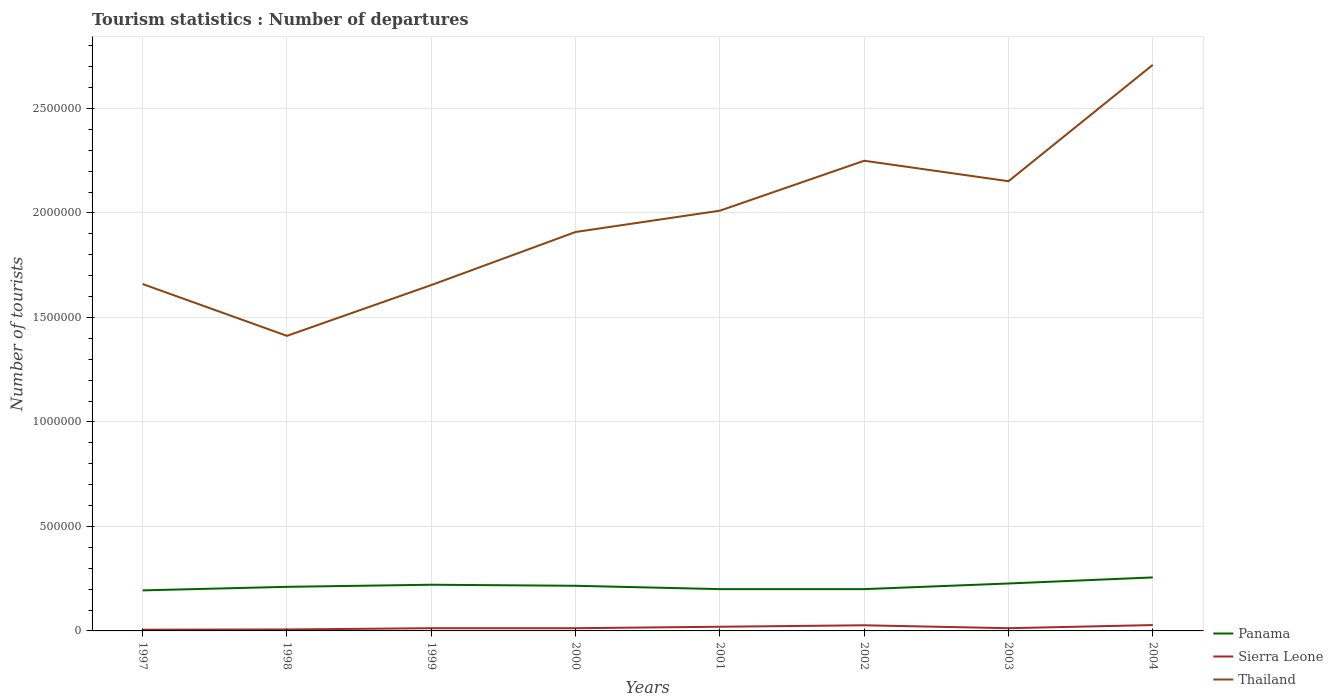How many different coloured lines are there?
Give a very brief answer. 3. Does the line corresponding to Sierra Leone intersect with the line corresponding to Thailand?
Keep it short and to the point. No. Across all years, what is the maximum number of tourist departures in Thailand?
Provide a succinct answer. 1.41e+06. What is the total number of tourist departures in Thailand in the graph?
Provide a short and direct response. -5.90e+05. What is the difference between the highest and the second highest number of tourist departures in Thailand?
Your answer should be compact. 1.30e+06. What is the difference between the highest and the lowest number of tourist departures in Thailand?
Provide a succinct answer. 4. Is the number of tourist departures in Thailand strictly greater than the number of tourist departures in Panama over the years?
Make the answer very short. No. How many years are there in the graph?
Provide a short and direct response. 8. Are the values on the major ticks of Y-axis written in scientific E-notation?
Offer a terse response. No. Does the graph contain any zero values?
Provide a short and direct response. No. Where does the legend appear in the graph?
Keep it short and to the point. Bottom right. How many legend labels are there?
Give a very brief answer. 3. How are the legend labels stacked?
Give a very brief answer. Vertical. What is the title of the graph?
Offer a very short reply. Tourism statistics : Number of departures. Does "Canada" appear as one of the legend labels in the graph?
Your response must be concise. No. What is the label or title of the X-axis?
Your response must be concise. Years. What is the label or title of the Y-axis?
Offer a terse response. Number of tourists. What is the Number of tourists of Panama in 1997?
Offer a terse response. 1.94e+05. What is the Number of tourists in Sierra Leone in 1997?
Offer a very short reply. 6000. What is the Number of tourists of Thailand in 1997?
Your answer should be compact. 1.66e+06. What is the Number of tourists of Panama in 1998?
Provide a short and direct response. 2.11e+05. What is the Number of tourists in Sierra Leone in 1998?
Your response must be concise. 7000. What is the Number of tourists of Thailand in 1998?
Provide a succinct answer. 1.41e+06. What is the Number of tourists in Panama in 1999?
Make the answer very short. 2.21e+05. What is the Number of tourists of Sierra Leone in 1999?
Offer a terse response. 1.30e+04. What is the Number of tourists in Thailand in 1999?
Ensure brevity in your answer.  1.66e+06. What is the Number of tourists of Panama in 2000?
Keep it short and to the point. 2.16e+05. What is the Number of tourists in Sierra Leone in 2000?
Ensure brevity in your answer.  1.30e+04. What is the Number of tourists of Thailand in 2000?
Make the answer very short. 1.91e+06. What is the Number of tourists in Panama in 2001?
Give a very brief answer. 2.00e+05. What is the Number of tourists of Sierra Leone in 2001?
Offer a very short reply. 2.00e+04. What is the Number of tourists of Thailand in 2001?
Ensure brevity in your answer.  2.01e+06. What is the Number of tourists of Sierra Leone in 2002?
Make the answer very short. 2.70e+04. What is the Number of tourists of Thailand in 2002?
Offer a terse response. 2.25e+06. What is the Number of tourists in Panama in 2003?
Your answer should be compact. 2.27e+05. What is the Number of tourists in Sierra Leone in 2003?
Provide a succinct answer. 1.30e+04. What is the Number of tourists of Thailand in 2003?
Offer a very short reply. 2.15e+06. What is the Number of tourists of Panama in 2004?
Offer a terse response. 2.56e+05. What is the Number of tourists of Sierra Leone in 2004?
Offer a terse response. 2.80e+04. What is the Number of tourists in Thailand in 2004?
Provide a short and direct response. 2.71e+06. Across all years, what is the maximum Number of tourists of Panama?
Offer a very short reply. 2.56e+05. Across all years, what is the maximum Number of tourists of Sierra Leone?
Provide a succinct answer. 2.80e+04. Across all years, what is the maximum Number of tourists of Thailand?
Ensure brevity in your answer.  2.71e+06. Across all years, what is the minimum Number of tourists of Panama?
Give a very brief answer. 1.94e+05. Across all years, what is the minimum Number of tourists of Sierra Leone?
Provide a short and direct response. 6000. Across all years, what is the minimum Number of tourists of Thailand?
Your response must be concise. 1.41e+06. What is the total Number of tourists in Panama in the graph?
Your response must be concise. 1.72e+06. What is the total Number of tourists of Sierra Leone in the graph?
Give a very brief answer. 1.27e+05. What is the total Number of tourists in Thailand in the graph?
Give a very brief answer. 1.58e+07. What is the difference between the Number of tourists in Panama in 1997 and that in 1998?
Your response must be concise. -1.70e+04. What is the difference between the Number of tourists of Sierra Leone in 1997 and that in 1998?
Provide a short and direct response. -1000. What is the difference between the Number of tourists of Thailand in 1997 and that in 1998?
Ensure brevity in your answer.  2.48e+05. What is the difference between the Number of tourists in Panama in 1997 and that in 1999?
Keep it short and to the point. -2.70e+04. What is the difference between the Number of tourists in Sierra Leone in 1997 and that in 1999?
Your answer should be very brief. -7000. What is the difference between the Number of tourists in Panama in 1997 and that in 2000?
Provide a succinct answer. -2.20e+04. What is the difference between the Number of tourists in Sierra Leone in 1997 and that in 2000?
Your answer should be compact. -7000. What is the difference between the Number of tourists in Thailand in 1997 and that in 2000?
Give a very brief answer. -2.49e+05. What is the difference between the Number of tourists in Panama in 1997 and that in 2001?
Provide a short and direct response. -6000. What is the difference between the Number of tourists of Sierra Leone in 1997 and that in 2001?
Provide a succinct answer. -1.40e+04. What is the difference between the Number of tourists of Thailand in 1997 and that in 2001?
Keep it short and to the point. -3.51e+05. What is the difference between the Number of tourists of Panama in 1997 and that in 2002?
Your answer should be very brief. -6000. What is the difference between the Number of tourists in Sierra Leone in 1997 and that in 2002?
Offer a very short reply. -2.10e+04. What is the difference between the Number of tourists in Thailand in 1997 and that in 2002?
Offer a terse response. -5.90e+05. What is the difference between the Number of tourists in Panama in 1997 and that in 2003?
Offer a very short reply. -3.30e+04. What is the difference between the Number of tourists of Sierra Leone in 1997 and that in 2003?
Offer a very short reply. -7000. What is the difference between the Number of tourists in Thailand in 1997 and that in 2003?
Make the answer very short. -4.92e+05. What is the difference between the Number of tourists in Panama in 1997 and that in 2004?
Provide a short and direct response. -6.20e+04. What is the difference between the Number of tourists in Sierra Leone in 1997 and that in 2004?
Offer a terse response. -2.20e+04. What is the difference between the Number of tourists in Thailand in 1997 and that in 2004?
Keep it short and to the point. -1.05e+06. What is the difference between the Number of tourists of Panama in 1998 and that in 1999?
Make the answer very short. -10000. What is the difference between the Number of tourists of Sierra Leone in 1998 and that in 1999?
Offer a terse response. -6000. What is the difference between the Number of tourists in Thailand in 1998 and that in 1999?
Your answer should be compact. -2.43e+05. What is the difference between the Number of tourists of Panama in 1998 and that in 2000?
Your response must be concise. -5000. What is the difference between the Number of tourists in Sierra Leone in 1998 and that in 2000?
Give a very brief answer. -6000. What is the difference between the Number of tourists in Thailand in 1998 and that in 2000?
Make the answer very short. -4.97e+05. What is the difference between the Number of tourists in Panama in 1998 and that in 2001?
Offer a terse response. 1.10e+04. What is the difference between the Number of tourists of Sierra Leone in 1998 and that in 2001?
Make the answer very short. -1.30e+04. What is the difference between the Number of tourists in Thailand in 1998 and that in 2001?
Give a very brief answer. -5.99e+05. What is the difference between the Number of tourists in Panama in 1998 and that in 2002?
Offer a very short reply. 1.10e+04. What is the difference between the Number of tourists in Thailand in 1998 and that in 2002?
Give a very brief answer. -8.38e+05. What is the difference between the Number of tourists of Panama in 1998 and that in 2003?
Keep it short and to the point. -1.60e+04. What is the difference between the Number of tourists of Sierra Leone in 1998 and that in 2003?
Keep it short and to the point. -6000. What is the difference between the Number of tourists in Thailand in 1998 and that in 2003?
Make the answer very short. -7.40e+05. What is the difference between the Number of tourists of Panama in 1998 and that in 2004?
Keep it short and to the point. -4.50e+04. What is the difference between the Number of tourists of Sierra Leone in 1998 and that in 2004?
Offer a terse response. -2.10e+04. What is the difference between the Number of tourists in Thailand in 1998 and that in 2004?
Provide a short and direct response. -1.30e+06. What is the difference between the Number of tourists of Thailand in 1999 and that in 2000?
Make the answer very short. -2.54e+05. What is the difference between the Number of tourists in Panama in 1999 and that in 2001?
Keep it short and to the point. 2.10e+04. What is the difference between the Number of tourists of Sierra Leone in 1999 and that in 2001?
Offer a very short reply. -7000. What is the difference between the Number of tourists in Thailand in 1999 and that in 2001?
Keep it short and to the point. -3.56e+05. What is the difference between the Number of tourists in Panama in 1999 and that in 2002?
Your answer should be very brief. 2.10e+04. What is the difference between the Number of tourists in Sierra Leone in 1999 and that in 2002?
Keep it short and to the point. -1.40e+04. What is the difference between the Number of tourists of Thailand in 1999 and that in 2002?
Make the answer very short. -5.95e+05. What is the difference between the Number of tourists in Panama in 1999 and that in 2003?
Provide a short and direct response. -6000. What is the difference between the Number of tourists of Thailand in 1999 and that in 2003?
Your answer should be very brief. -4.97e+05. What is the difference between the Number of tourists of Panama in 1999 and that in 2004?
Your response must be concise. -3.50e+04. What is the difference between the Number of tourists of Sierra Leone in 1999 and that in 2004?
Ensure brevity in your answer.  -1.50e+04. What is the difference between the Number of tourists in Thailand in 1999 and that in 2004?
Provide a short and direct response. -1.05e+06. What is the difference between the Number of tourists of Panama in 2000 and that in 2001?
Your answer should be compact. 1.60e+04. What is the difference between the Number of tourists of Sierra Leone in 2000 and that in 2001?
Give a very brief answer. -7000. What is the difference between the Number of tourists of Thailand in 2000 and that in 2001?
Make the answer very short. -1.02e+05. What is the difference between the Number of tourists in Panama in 2000 and that in 2002?
Your answer should be very brief. 1.60e+04. What is the difference between the Number of tourists of Sierra Leone in 2000 and that in 2002?
Provide a succinct answer. -1.40e+04. What is the difference between the Number of tourists of Thailand in 2000 and that in 2002?
Your response must be concise. -3.41e+05. What is the difference between the Number of tourists in Panama in 2000 and that in 2003?
Provide a succinct answer. -1.10e+04. What is the difference between the Number of tourists in Sierra Leone in 2000 and that in 2003?
Your answer should be very brief. 0. What is the difference between the Number of tourists of Thailand in 2000 and that in 2003?
Provide a succinct answer. -2.43e+05. What is the difference between the Number of tourists of Sierra Leone in 2000 and that in 2004?
Keep it short and to the point. -1.50e+04. What is the difference between the Number of tourists in Thailand in 2000 and that in 2004?
Provide a succinct answer. -8.00e+05. What is the difference between the Number of tourists in Sierra Leone in 2001 and that in 2002?
Offer a very short reply. -7000. What is the difference between the Number of tourists in Thailand in 2001 and that in 2002?
Offer a terse response. -2.39e+05. What is the difference between the Number of tourists in Panama in 2001 and that in 2003?
Offer a terse response. -2.70e+04. What is the difference between the Number of tourists in Sierra Leone in 2001 and that in 2003?
Offer a terse response. 7000. What is the difference between the Number of tourists in Thailand in 2001 and that in 2003?
Provide a short and direct response. -1.41e+05. What is the difference between the Number of tourists in Panama in 2001 and that in 2004?
Offer a terse response. -5.60e+04. What is the difference between the Number of tourists in Sierra Leone in 2001 and that in 2004?
Provide a succinct answer. -8000. What is the difference between the Number of tourists in Thailand in 2001 and that in 2004?
Provide a short and direct response. -6.98e+05. What is the difference between the Number of tourists of Panama in 2002 and that in 2003?
Ensure brevity in your answer.  -2.70e+04. What is the difference between the Number of tourists in Sierra Leone in 2002 and that in 2003?
Keep it short and to the point. 1.40e+04. What is the difference between the Number of tourists of Thailand in 2002 and that in 2003?
Your answer should be very brief. 9.80e+04. What is the difference between the Number of tourists in Panama in 2002 and that in 2004?
Offer a terse response. -5.60e+04. What is the difference between the Number of tourists of Sierra Leone in 2002 and that in 2004?
Provide a succinct answer. -1000. What is the difference between the Number of tourists of Thailand in 2002 and that in 2004?
Your response must be concise. -4.59e+05. What is the difference between the Number of tourists of Panama in 2003 and that in 2004?
Keep it short and to the point. -2.90e+04. What is the difference between the Number of tourists in Sierra Leone in 2003 and that in 2004?
Offer a very short reply. -1.50e+04. What is the difference between the Number of tourists of Thailand in 2003 and that in 2004?
Keep it short and to the point. -5.57e+05. What is the difference between the Number of tourists of Panama in 1997 and the Number of tourists of Sierra Leone in 1998?
Give a very brief answer. 1.87e+05. What is the difference between the Number of tourists in Panama in 1997 and the Number of tourists in Thailand in 1998?
Make the answer very short. -1.22e+06. What is the difference between the Number of tourists in Sierra Leone in 1997 and the Number of tourists in Thailand in 1998?
Your answer should be very brief. -1.41e+06. What is the difference between the Number of tourists in Panama in 1997 and the Number of tourists in Sierra Leone in 1999?
Your answer should be compact. 1.81e+05. What is the difference between the Number of tourists of Panama in 1997 and the Number of tourists of Thailand in 1999?
Give a very brief answer. -1.46e+06. What is the difference between the Number of tourists of Sierra Leone in 1997 and the Number of tourists of Thailand in 1999?
Give a very brief answer. -1.65e+06. What is the difference between the Number of tourists of Panama in 1997 and the Number of tourists of Sierra Leone in 2000?
Make the answer very short. 1.81e+05. What is the difference between the Number of tourists of Panama in 1997 and the Number of tourists of Thailand in 2000?
Offer a terse response. -1.72e+06. What is the difference between the Number of tourists in Sierra Leone in 1997 and the Number of tourists in Thailand in 2000?
Your answer should be compact. -1.90e+06. What is the difference between the Number of tourists in Panama in 1997 and the Number of tourists in Sierra Leone in 2001?
Ensure brevity in your answer.  1.74e+05. What is the difference between the Number of tourists in Panama in 1997 and the Number of tourists in Thailand in 2001?
Your answer should be compact. -1.82e+06. What is the difference between the Number of tourists in Sierra Leone in 1997 and the Number of tourists in Thailand in 2001?
Your answer should be very brief. -2.00e+06. What is the difference between the Number of tourists of Panama in 1997 and the Number of tourists of Sierra Leone in 2002?
Ensure brevity in your answer.  1.67e+05. What is the difference between the Number of tourists in Panama in 1997 and the Number of tourists in Thailand in 2002?
Provide a short and direct response. -2.06e+06. What is the difference between the Number of tourists in Sierra Leone in 1997 and the Number of tourists in Thailand in 2002?
Your answer should be very brief. -2.24e+06. What is the difference between the Number of tourists of Panama in 1997 and the Number of tourists of Sierra Leone in 2003?
Offer a very short reply. 1.81e+05. What is the difference between the Number of tourists of Panama in 1997 and the Number of tourists of Thailand in 2003?
Your response must be concise. -1.96e+06. What is the difference between the Number of tourists of Sierra Leone in 1997 and the Number of tourists of Thailand in 2003?
Offer a terse response. -2.15e+06. What is the difference between the Number of tourists in Panama in 1997 and the Number of tourists in Sierra Leone in 2004?
Make the answer very short. 1.66e+05. What is the difference between the Number of tourists of Panama in 1997 and the Number of tourists of Thailand in 2004?
Offer a very short reply. -2.52e+06. What is the difference between the Number of tourists of Sierra Leone in 1997 and the Number of tourists of Thailand in 2004?
Keep it short and to the point. -2.70e+06. What is the difference between the Number of tourists in Panama in 1998 and the Number of tourists in Sierra Leone in 1999?
Your response must be concise. 1.98e+05. What is the difference between the Number of tourists of Panama in 1998 and the Number of tourists of Thailand in 1999?
Provide a succinct answer. -1.44e+06. What is the difference between the Number of tourists in Sierra Leone in 1998 and the Number of tourists in Thailand in 1999?
Give a very brief answer. -1.65e+06. What is the difference between the Number of tourists of Panama in 1998 and the Number of tourists of Sierra Leone in 2000?
Your response must be concise. 1.98e+05. What is the difference between the Number of tourists in Panama in 1998 and the Number of tourists in Thailand in 2000?
Your response must be concise. -1.70e+06. What is the difference between the Number of tourists in Sierra Leone in 1998 and the Number of tourists in Thailand in 2000?
Offer a very short reply. -1.90e+06. What is the difference between the Number of tourists of Panama in 1998 and the Number of tourists of Sierra Leone in 2001?
Give a very brief answer. 1.91e+05. What is the difference between the Number of tourists of Panama in 1998 and the Number of tourists of Thailand in 2001?
Ensure brevity in your answer.  -1.80e+06. What is the difference between the Number of tourists of Sierra Leone in 1998 and the Number of tourists of Thailand in 2001?
Give a very brief answer. -2.00e+06. What is the difference between the Number of tourists of Panama in 1998 and the Number of tourists of Sierra Leone in 2002?
Ensure brevity in your answer.  1.84e+05. What is the difference between the Number of tourists of Panama in 1998 and the Number of tourists of Thailand in 2002?
Provide a succinct answer. -2.04e+06. What is the difference between the Number of tourists in Sierra Leone in 1998 and the Number of tourists in Thailand in 2002?
Ensure brevity in your answer.  -2.24e+06. What is the difference between the Number of tourists of Panama in 1998 and the Number of tourists of Sierra Leone in 2003?
Your answer should be compact. 1.98e+05. What is the difference between the Number of tourists in Panama in 1998 and the Number of tourists in Thailand in 2003?
Offer a terse response. -1.94e+06. What is the difference between the Number of tourists in Sierra Leone in 1998 and the Number of tourists in Thailand in 2003?
Provide a short and direct response. -2.14e+06. What is the difference between the Number of tourists in Panama in 1998 and the Number of tourists in Sierra Leone in 2004?
Make the answer very short. 1.83e+05. What is the difference between the Number of tourists of Panama in 1998 and the Number of tourists of Thailand in 2004?
Make the answer very short. -2.50e+06. What is the difference between the Number of tourists of Sierra Leone in 1998 and the Number of tourists of Thailand in 2004?
Give a very brief answer. -2.70e+06. What is the difference between the Number of tourists in Panama in 1999 and the Number of tourists in Sierra Leone in 2000?
Make the answer very short. 2.08e+05. What is the difference between the Number of tourists of Panama in 1999 and the Number of tourists of Thailand in 2000?
Your response must be concise. -1.69e+06. What is the difference between the Number of tourists of Sierra Leone in 1999 and the Number of tourists of Thailand in 2000?
Your answer should be compact. -1.90e+06. What is the difference between the Number of tourists of Panama in 1999 and the Number of tourists of Sierra Leone in 2001?
Offer a terse response. 2.01e+05. What is the difference between the Number of tourists in Panama in 1999 and the Number of tourists in Thailand in 2001?
Offer a very short reply. -1.79e+06. What is the difference between the Number of tourists in Sierra Leone in 1999 and the Number of tourists in Thailand in 2001?
Offer a very short reply. -2.00e+06. What is the difference between the Number of tourists in Panama in 1999 and the Number of tourists in Sierra Leone in 2002?
Offer a very short reply. 1.94e+05. What is the difference between the Number of tourists of Panama in 1999 and the Number of tourists of Thailand in 2002?
Offer a very short reply. -2.03e+06. What is the difference between the Number of tourists in Sierra Leone in 1999 and the Number of tourists in Thailand in 2002?
Provide a succinct answer. -2.24e+06. What is the difference between the Number of tourists of Panama in 1999 and the Number of tourists of Sierra Leone in 2003?
Make the answer very short. 2.08e+05. What is the difference between the Number of tourists in Panama in 1999 and the Number of tourists in Thailand in 2003?
Your answer should be very brief. -1.93e+06. What is the difference between the Number of tourists in Sierra Leone in 1999 and the Number of tourists in Thailand in 2003?
Offer a terse response. -2.14e+06. What is the difference between the Number of tourists in Panama in 1999 and the Number of tourists in Sierra Leone in 2004?
Give a very brief answer. 1.93e+05. What is the difference between the Number of tourists in Panama in 1999 and the Number of tourists in Thailand in 2004?
Your answer should be compact. -2.49e+06. What is the difference between the Number of tourists of Sierra Leone in 1999 and the Number of tourists of Thailand in 2004?
Provide a succinct answer. -2.70e+06. What is the difference between the Number of tourists in Panama in 2000 and the Number of tourists in Sierra Leone in 2001?
Your answer should be compact. 1.96e+05. What is the difference between the Number of tourists of Panama in 2000 and the Number of tourists of Thailand in 2001?
Offer a terse response. -1.80e+06. What is the difference between the Number of tourists of Sierra Leone in 2000 and the Number of tourists of Thailand in 2001?
Keep it short and to the point. -2.00e+06. What is the difference between the Number of tourists of Panama in 2000 and the Number of tourists of Sierra Leone in 2002?
Make the answer very short. 1.89e+05. What is the difference between the Number of tourists in Panama in 2000 and the Number of tourists in Thailand in 2002?
Ensure brevity in your answer.  -2.03e+06. What is the difference between the Number of tourists in Sierra Leone in 2000 and the Number of tourists in Thailand in 2002?
Your answer should be compact. -2.24e+06. What is the difference between the Number of tourists of Panama in 2000 and the Number of tourists of Sierra Leone in 2003?
Provide a short and direct response. 2.03e+05. What is the difference between the Number of tourists in Panama in 2000 and the Number of tourists in Thailand in 2003?
Your answer should be compact. -1.94e+06. What is the difference between the Number of tourists in Sierra Leone in 2000 and the Number of tourists in Thailand in 2003?
Keep it short and to the point. -2.14e+06. What is the difference between the Number of tourists in Panama in 2000 and the Number of tourists in Sierra Leone in 2004?
Your answer should be compact. 1.88e+05. What is the difference between the Number of tourists in Panama in 2000 and the Number of tourists in Thailand in 2004?
Provide a succinct answer. -2.49e+06. What is the difference between the Number of tourists of Sierra Leone in 2000 and the Number of tourists of Thailand in 2004?
Provide a short and direct response. -2.70e+06. What is the difference between the Number of tourists of Panama in 2001 and the Number of tourists of Sierra Leone in 2002?
Provide a succinct answer. 1.73e+05. What is the difference between the Number of tourists of Panama in 2001 and the Number of tourists of Thailand in 2002?
Make the answer very short. -2.05e+06. What is the difference between the Number of tourists in Sierra Leone in 2001 and the Number of tourists in Thailand in 2002?
Ensure brevity in your answer.  -2.23e+06. What is the difference between the Number of tourists in Panama in 2001 and the Number of tourists in Sierra Leone in 2003?
Give a very brief answer. 1.87e+05. What is the difference between the Number of tourists of Panama in 2001 and the Number of tourists of Thailand in 2003?
Your response must be concise. -1.95e+06. What is the difference between the Number of tourists of Sierra Leone in 2001 and the Number of tourists of Thailand in 2003?
Your answer should be very brief. -2.13e+06. What is the difference between the Number of tourists of Panama in 2001 and the Number of tourists of Sierra Leone in 2004?
Provide a succinct answer. 1.72e+05. What is the difference between the Number of tourists of Panama in 2001 and the Number of tourists of Thailand in 2004?
Keep it short and to the point. -2.51e+06. What is the difference between the Number of tourists of Sierra Leone in 2001 and the Number of tourists of Thailand in 2004?
Give a very brief answer. -2.69e+06. What is the difference between the Number of tourists in Panama in 2002 and the Number of tourists in Sierra Leone in 2003?
Offer a very short reply. 1.87e+05. What is the difference between the Number of tourists in Panama in 2002 and the Number of tourists in Thailand in 2003?
Offer a terse response. -1.95e+06. What is the difference between the Number of tourists in Sierra Leone in 2002 and the Number of tourists in Thailand in 2003?
Your answer should be compact. -2.12e+06. What is the difference between the Number of tourists of Panama in 2002 and the Number of tourists of Sierra Leone in 2004?
Your response must be concise. 1.72e+05. What is the difference between the Number of tourists of Panama in 2002 and the Number of tourists of Thailand in 2004?
Offer a terse response. -2.51e+06. What is the difference between the Number of tourists in Sierra Leone in 2002 and the Number of tourists in Thailand in 2004?
Give a very brief answer. -2.68e+06. What is the difference between the Number of tourists in Panama in 2003 and the Number of tourists in Sierra Leone in 2004?
Make the answer very short. 1.99e+05. What is the difference between the Number of tourists of Panama in 2003 and the Number of tourists of Thailand in 2004?
Offer a terse response. -2.48e+06. What is the difference between the Number of tourists in Sierra Leone in 2003 and the Number of tourists in Thailand in 2004?
Keep it short and to the point. -2.70e+06. What is the average Number of tourists in Panama per year?
Your answer should be compact. 2.16e+05. What is the average Number of tourists in Sierra Leone per year?
Your answer should be very brief. 1.59e+04. What is the average Number of tourists of Thailand per year?
Give a very brief answer. 1.97e+06. In the year 1997, what is the difference between the Number of tourists in Panama and Number of tourists in Sierra Leone?
Give a very brief answer. 1.88e+05. In the year 1997, what is the difference between the Number of tourists of Panama and Number of tourists of Thailand?
Offer a very short reply. -1.47e+06. In the year 1997, what is the difference between the Number of tourists in Sierra Leone and Number of tourists in Thailand?
Keep it short and to the point. -1.65e+06. In the year 1998, what is the difference between the Number of tourists of Panama and Number of tourists of Sierra Leone?
Your response must be concise. 2.04e+05. In the year 1998, what is the difference between the Number of tourists in Panama and Number of tourists in Thailand?
Your answer should be compact. -1.20e+06. In the year 1998, what is the difference between the Number of tourists of Sierra Leone and Number of tourists of Thailand?
Provide a short and direct response. -1.40e+06. In the year 1999, what is the difference between the Number of tourists in Panama and Number of tourists in Sierra Leone?
Your response must be concise. 2.08e+05. In the year 1999, what is the difference between the Number of tourists in Panama and Number of tourists in Thailand?
Ensure brevity in your answer.  -1.43e+06. In the year 1999, what is the difference between the Number of tourists of Sierra Leone and Number of tourists of Thailand?
Give a very brief answer. -1.64e+06. In the year 2000, what is the difference between the Number of tourists of Panama and Number of tourists of Sierra Leone?
Your response must be concise. 2.03e+05. In the year 2000, what is the difference between the Number of tourists in Panama and Number of tourists in Thailand?
Offer a terse response. -1.69e+06. In the year 2000, what is the difference between the Number of tourists in Sierra Leone and Number of tourists in Thailand?
Give a very brief answer. -1.90e+06. In the year 2001, what is the difference between the Number of tourists in Panama and Number of tourists in Thailand?
Make the answer very short. -1.81e+06. In the year 2001, what is the difference between the Number of tourists in Sierra Leone and Number of tourists in Thailand?
Your answer should be very brief. -1.99e+06. In the year 2002, what is the difference between the Number of tourists in Panama and Number of tourists in Sierra Leone?
Keep it short and to the point. 1.73e+05. In the year 2002, what is the difference between the Number of tourists in Panama and Number of tourists in Thailand?
Make the answer very short. -2.05e+06. In the year 2002, what is the difference between the Number of tourists of Sierra Leone and Number of tourists of Thailand?
Provide a succinct answer. -2.22e+06. In the year 2003, what is the difference between the Number of tourists of Panama and Number of tourists of Sierra Leone?
Offer a very short reply. 2.14e+05. In the year 2003, what is the difference between the Number of tourists of Panama and Number of tourists of Thailand?
Your answer should be very brief. -1.92e+06. In the year 2003, what is the difference between the Number of tourists of Sierra Leone and Number of tourists of Thailand?
Provide a short and direct response. -2.14e+06. In the year 2004, what is the difference between the Number of tourists in Panama and Number of tourists in Sierra Leone?
Keep it short and to the point. 2.28e+05. In the year 2004, what is the difference between the Number of tourists of Panama and Number of tourists of Thailand?
Your answer should be compact. -2.45e+06. In the year 2004, what is the difference between the Number of tourists of Sierra Leone and Number of tourists of Thailand?
Your answer should be compact. -2.68e+06. What is the ratio of the Number of tourists of Panama in 1997 to that in 1998?
Give a very brief answer. 0.92. What is the ratio of the Number of tourists in Sierra Leone in 1997 to that in 1998?
Provide a short and direct response. 0.86. What is the ratio of the Number of tourists of Thailand in 1997 to that in 1998?
Provide a short and direct response. 1.18. What is the ratio of the Number of tourists in Panama in 1997 to that in 1999?
Provide a succinct answer. 0.88. What is the ratio of the Number of tourists of Sierra Leone in 1997 to that in 1999?
Your answer should be compact. 0.46. What is the ratio of the Number of tourists of Thailand in 1997 to that in 1999?
Offer a very short reply. 1. What is the ratio of the Number of tourists in Panama in 1997 to that in 2000?
Your response must be concise. 0.9. What is the ratio of the Number of tourists in Sierra Leone in 1997 to that in 2000?
Ensure brevity in your answer.  0.46. What is the ratio of the Number of tourists in Thailand in 1997 to that in 2000?
Your answer should be compact. 0.87. What is the ratio of the Number of tourists in Sierra Leone in 1997 to that in 2001?
Provide a short and direct response. 0.3. What is the ratio of the Number of tourists of Thailand in 1997 to that in 2001?
Your answer should be very brief. 0.83. What is the ratio of the Number of tourists in Panama in 1997 to that in 2002?
Make the answer very short. 0.97. What is the ratio of the Number of tourists in Sierra Leone in 1997 to that in 2002?
Provide a short and direct response. 0.22. What is the ratio of the Number of tourists in Thailand in 1997 to that in 2002?
Ensure brevity in your answer.  0.74. What is the ratio of the Number of tourists in Panama in 1997 to that in 2003?
Ensure brevity in your answer.  0.85. What is the ratio of the Number of tourists in Sierra Leone in 1997 to that in 2003?
Your answer should be very brief. 0.46. What is the ratio of the Number of tourists in Thailand in 1997 to that in 2003?
Keep it short and to the point. 0.77. What is the ratio of the Number of tourists of Panama in 1997 to that in 2004?
Offer a very short reply. 0.76. What is the ratio of the Number of tourists in Sierra Leone in 1997 to that in 2004?
Your answer should be compact. 0.21. What is the ratio of the Number of tourists in Thailand in 1997 to that in 2004?
Offer a very short reply. 0.61. What is the ratio of the Number of tourists of Panama in 1998 to that in 1999?
Provide a succinct answer. 0.95. What is the ratio of the Number of tourists in Sierra Leone in 1998 to that in 1999?
Ensure brevity in your answer.  0.54. What is the ratio of the Number of tourists of Thailand in 1998 to that in 1999?
Give a very brief answer. 0.85. What is the ratio of the Number of tourists of Panama in 1998 to that in 2000?
Make the answer very short. 0.98. What is the ratio of the Number of tourists of Sierra Leone in 1998 to that in 2000?
Your answer should be compact. 0.54. What is the ratio of the Number of tourists of Thailand in 1998 to that in 2000?
Keep it short and to the point. 0.74. What is the ratio of the Number of tourists in Panama in 1998 to that in 2001?
Provide a short and direct response. 1.05. What is the ratio of the Number of tourists in Sierra Leone in 1998 to that in 2001?
Provide a short and direct response. 0.35. What is the ratio of the Number of tourists in Thailand in 1998 to that in 2001?
Keep it short and to the point. 0.7. What is the ratio of the Number of tourists of Panama in 1998 to that in 2002?
Your answer should be very brief. 1.05. What is the ratio of the Number of tourists of Sierra Leone in 1998 to that in 2002?
Provide a short and direct response. 0.26. What is the ratio of the Number of tourists in Thailand in 1998 to that in 2002?
Provide a short and direct response. 0.63. What is the ratio of the Number of tourists in Panama in 1998 to that in 2003?
Give a very brief answer. 0.93. What is the ratio of the Number of tourists in Sierra Leone in 1998 to that in 2003?
Provide a succinct answer. 0.54. What is the ratio of the Number of tourists of Thailand in 1998 to that in 2003?
Give a very brief answer. 0.66. What is the ratio of the Number of tourists of Panama in 1998 to that in 2004?
Your response must be concise. 0.82. What is the ratio of the Number of tourists in Thailand in 1998 to that in 2004?
Keep it short and to the point. 0.52. What is the ratio of the Number of tourists in Panama in 1999 to that in 2000?
Offer a terse response. 1.02. What is the ratio of the Number of tourists of Sierra Leone in 1999 to that in 2000?
Offer a terse response. 1. What is the ratio of the Number of tourists of Thailand in 1999 to that in 2000?
Keep it short and to the point. 0.87. What is the ratio of the Number of tourists of Panama in 1999 to that in 2001?
Ensure brevity in your answer.  1.1. What is the ratio of the Number of tourists of Sierra Leone in 1999 to that in 2001?
Offer a terse response. 0.65. What is the ratio of the Number of tourists of Thailand in 1999 to that in 2001?
Your answer should be compact. 0.82. What is the ratio of the Number of tourists in Panama in 1999 to that in 2002?
Your answer should be very brief. 1.1. What is the ratio of the Number of tourists of Sierra Leone in 1999 to that in 2002?
Offer a terse response. 0.48. What is the ratio of the Number of tourists in Thailand in 1999 to that in 2002?
Ensure brevity in your answer.  0.74. What is the ratio of the Number of tourists of Panama in 1999 to that in 2003?
Offer a terse response. 0.97. What is the ratio of the Number of tourists in Thailand in 1999 to that in 2003?
Keep it short and to the point. 0.77. What is the ratio of the Number of tourists in Panama in 1999 to that in 2004?
Your answer should be very brief. 0.86. What is the ratio of the Number of tourists in Sierra Leone in 1999 to that in 2004?
Your answer should be compact. 0.46. What is the ratio of the Number of tourists in Thailand in 1999 to that in 2004?
Your answer should be compact. 0.61. What is the ratio of the Number of tourists of Sierra Leone in 2000 to that in 2001?
Your answer should be very brief. 0.65. What is the ratio of the Number of tourists of Thailand in 2000 to that in 2001?
Provide a short and direct response. 0.95. What is the ratio of the Number of tourists in Panama in 2000 to that in 2002?
Provide a short and direct response. 1.08. What is the ratio of the Number of tourists in Sierra Leone in 2000 to that in 2002?
Your answer should be very brief. 0.48. What is the ratio of the Number of tourists of Thailand in 2000 to that in 2002?
Keep it short and to the point. 0.85. What is the ratio of the Number of tourists in Panama in 2000 to that in 2003?
Offer a terse response. 0.95. What is the ratio of the Number of tourists in Thailand in 2000 to that in 2003?
Your response must be concise. 0.89. What is the ratio of the Number of tourists in Panama in 2000 to that in 2004?
Keep it short and to the point. 0.84. What is the ratio of the Number of tourists in Sierra Leone in 2000 to that in 2004?
Your response must be concise. 0.46. What is the ratio of the Number of tourists in Thailand in 2000 to that in 2004?
Offer a very short reply. 0.7. What is the ratio of the Number of tourists of Panama in 2001 to that in 2002?
Your answer should be very brief. 1. What is the ratio of the Number of tourists in Sierra Leone in 2001 to that in 2002?
Offer a terse response. 0.74. What is the ratio of the Number of tourists in Thailand in 2001 to that in 2002?
Provide a succinct answer. 0.89. What is the ratio of the Number of tourists of Panama in 2001 to that in 2003?
Give a very brief answer. 0.88. What is the ratio of the Number of tourists in Sierra Leone in 2001 to that in 2003?
Provide a succinct answer. 1.54. What is the ratio of the Number of tourists of Thailand in 2001 to that in 2003?
Offer a terse response. 0.93. What is the ratio of the Number of tourists of Panama in 2001 to that in 2004?
Keep it short and to the point. 0.78. What is the ratio of the Number of tourists of Thailand in 2001 to that in 2004?
Make the answer very short. 0.74. What is the ratio of the Number of tourists of Panama in 2002 to that in 2003?
Provide a succinct answer. 0.88. What is the ratio of the Number of tourists of Sierra Leone in 2002 to that in 2003?
Ensure brevity in your answer.  2.08. What is the ratio of the Number of tourists in Thailand in 2002 to that in 2003?
Provide a succinct answer. 1.05. What is the ratio of the Number of tourists in Panama in 2002 to that in 2004?
Offer a very short reply. 0.78. What is the ratio of the Number of tourists of Sierra Leone in 2002 to that in 2004?
Provide a short and direct response. 0.96. What is the ratio of the Number of tourists in Thailand in 2002 to that in 2004?
Make the answer very short. 0.83. What is the ratio of the Number of tourists of Panama in 2003 to that in 2004?
Provide a short and direct response. 0.89. What is the ratio of the Number of tourists in Sierra Leone in 2003 to that in 2004?
Offer a terse response. 0.46. What is the ratio of the Number of tourists of Thailand in 2003 to that in 2004?
Your answer should be very brief. 0.79. What is the difference between the highest and the second highest Number of tourists in Panama?
Offer a very short reply. 2.90e+04. What is the difference between the highest and the second highest Number of tourists of Sierra Leone?
Provide a succinct answer. 1000. What is the difference between the highest and the second highest Number of tourists in Thailand?
Your answer should be compact. 4.59e+05. What is the difference between the highest and the lowest Number of tourists of Panama?
Make the answer very short. 6.20e+04. What is the difference between the highest and the lowest Number of tourists in Sierra Leone?
Ensure brevity in your answer.  2.20e+04. What is the difference between the highest and the lowest Number of tourists in Thailand?
Provide a succinct answer. 1.30e+06. 